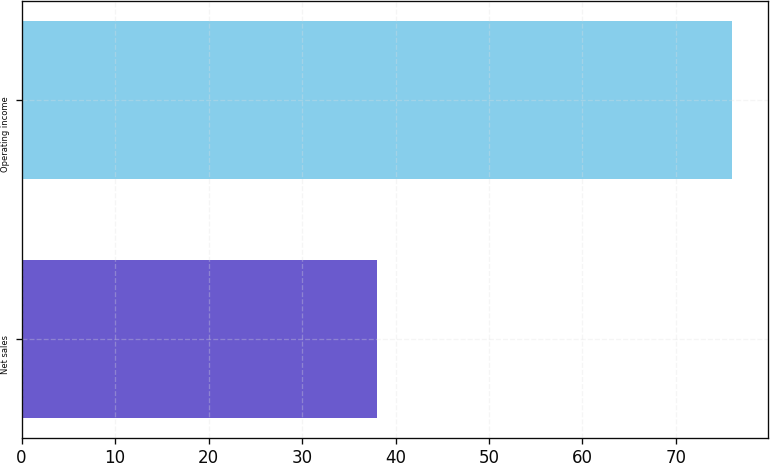<chart> <loc_0><loc_0><loc_500><loc_500><bar_chart><fcel>Net sales<fcel>Operating income<nl><fcel>38<fcel>76<nl></chart> 